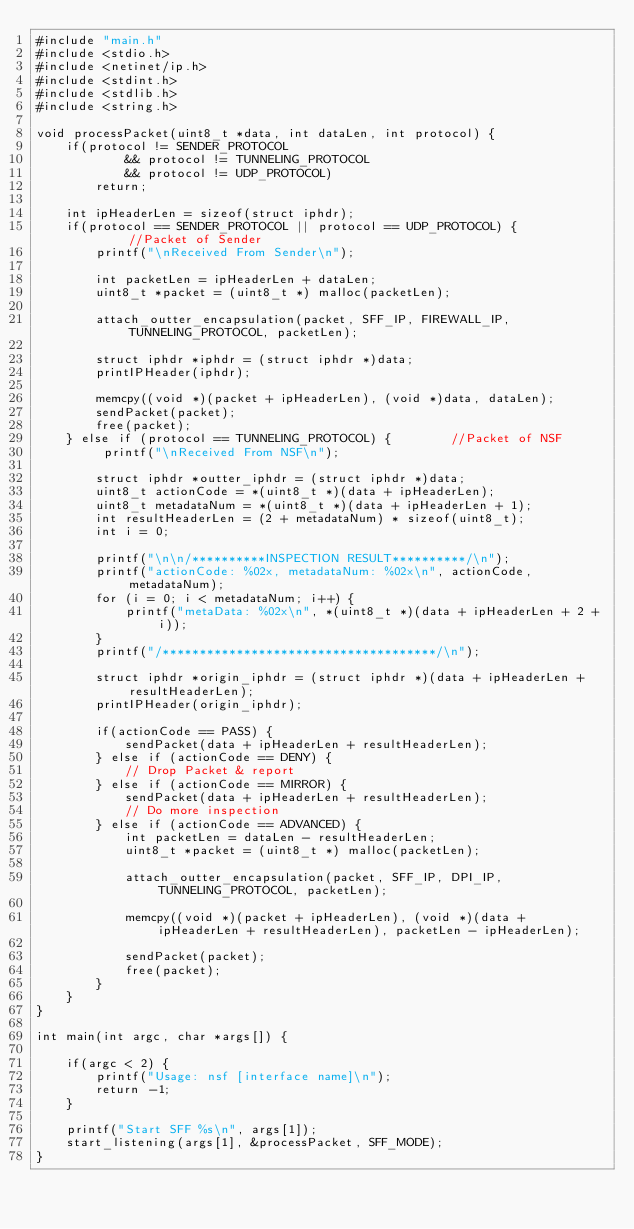<code> <loc_0><loc_0><loc_500><loc_500><_C_>#include "main.h"
#include <stdio.h>
#include <netinet/ip.h>
#include <stdint.h>
#include <stdlib.h>
#include <string.h>

void processPacket(uint8_t *data, int dataLen, int protocol) {
    if(protocol != SENDER_PROTOCOL 
			&& protocol != TUNNELING_PROTOCOL
			&& protocol != UDP_PROTOCOL) 
		return;

    int ipHeaderLen = sizeof(struct iphdr);
    if(protocol == SENDER_PROTOCOL || protocol == UDP_PROTOCOL) {				//Packet of Sender
        printf("\nReceived From Sender\n");

        int packetLen = ipHeaderLen + dataLen;
        uint8_t *packet = (uint8_t *) malloc(packetLen);

        attach_outter_encapsulation(packet, SFF_IP, FIREWALL_IP, TUNNELING_PROTOCOL, packetLen);

        struct iphdr *iphdr = (struct iphdr *)data;
        printIPHeader(iphdr);

        memcpy((void *)(packet + ipHeaderLen), (void *)data, dataLen);
        sendPacket(packet);
        free(packet);
    } else if (protocol == TUNNELING_PROTOCOL) {		//Packet of NSF
         printf("\nReceived From NSF\n");

        struct iphdr *outter_iphdr = (struct iphdr *)data;
        uint8_t actionCode = *(uint8_t *)(data + ipHeaderLen);
        uint8_t metadataNum = *(uint8_t *)(data + ipHeaderLen + 1);
		int resultHeaderLen = (2 + metadataNum) * sizeof(uint8_t);
        int i = 0;

        printf("\n\n/**********INSPECTION RESULT**********/\n");
        printf("actionCode: %02x, metadataNum: %02x\n", actionCode, metadataNum);
        for (i = 0; i < metadataNum; i++) {
            printf("metaData: %02x\n", *(uint8_t *)(data + ipHeaderLen + 2 + i));
        }
        printf("/*************************************/\n");

        struct iphdr *origin_iphdr = (struct iphdr *)(data + ipHeaderLen + resultHeaderLen);
        printIPHeader(origin_iphdr);

        if(actionCode == PASS) {
            sendPacket(data + ipHeaderLen + resultHeaderLen);
        } else if (actionCode == DENY) {
            // Drop Packet & report
        } else if (actionCode == MIRROR) {
            sendPacket(data + ipHeaderLen + resultHeaderLen);
            // Do more inspection
        } else if (actionCode == ADVANCED) {
			int packetLen = dataLen - resultHeaderLen;
			uint8_t *packet = (uint8_t *) malloc(packetLen);

			attach_outter_encapsulation(packet, SFF_IP, DPI_IP, TUNNELING_PROTOCOL, packetLen);

			memcpy((void *)(packet + ipHeaderLen), (void *)(data + ipHeaderLen + resultHeaderLen), packetLen - ipHeaderLen);

			sendPacket(packet);
			free(packet);
        }
    }
}

int main(int argc, char *args[]) {

    if(argc < 2) {
        printf("Usage: nsf [interface name]\n");
        return -1;
    }

    printf("Start SFF %s\n", args[1]);
    start_listening(args[1], &processPacket, SFF_MODE);
}
</code> 